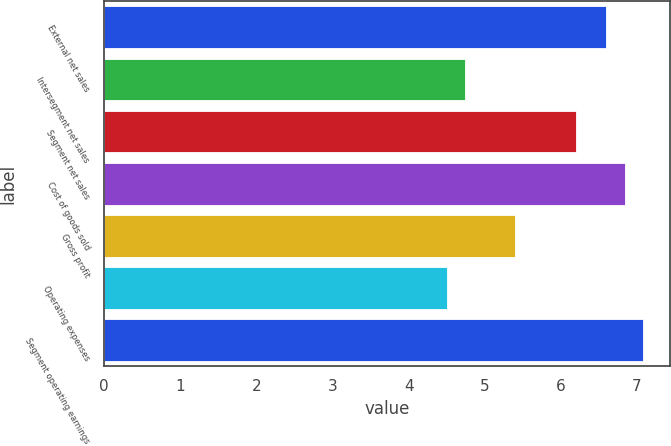<chart> <loc_0><loc_0><loc_500><loc_500><bar_chart><fcel>External net sales<fcel>Intersegment net sales<fcel>Segment net sales<fcel>Cost of goods sold<fcel>Gross profit<fcel>Operating expenses<fcel>Segment operating earnings<nl><fcel>6.6<fcel>4.74<fcel>6.2<fcel>6.84<fcel>5.4<fcel>4.5<fcel>7.08<nl></chart> 